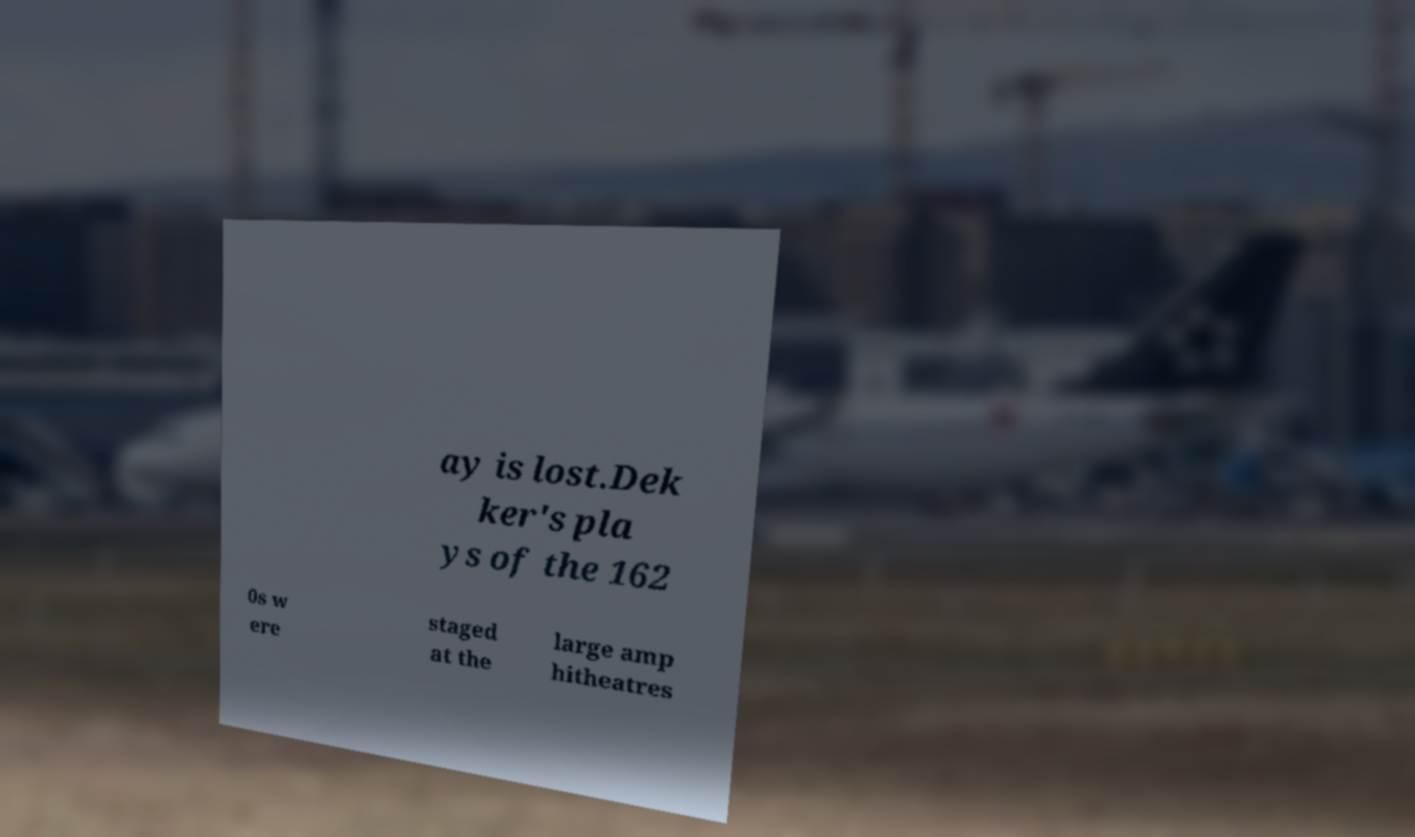Please identify and transcribe the text found in this image. ay is lost.Dek ker's pla ys of the 162 0s w ere staged at the large amp hitheatres 